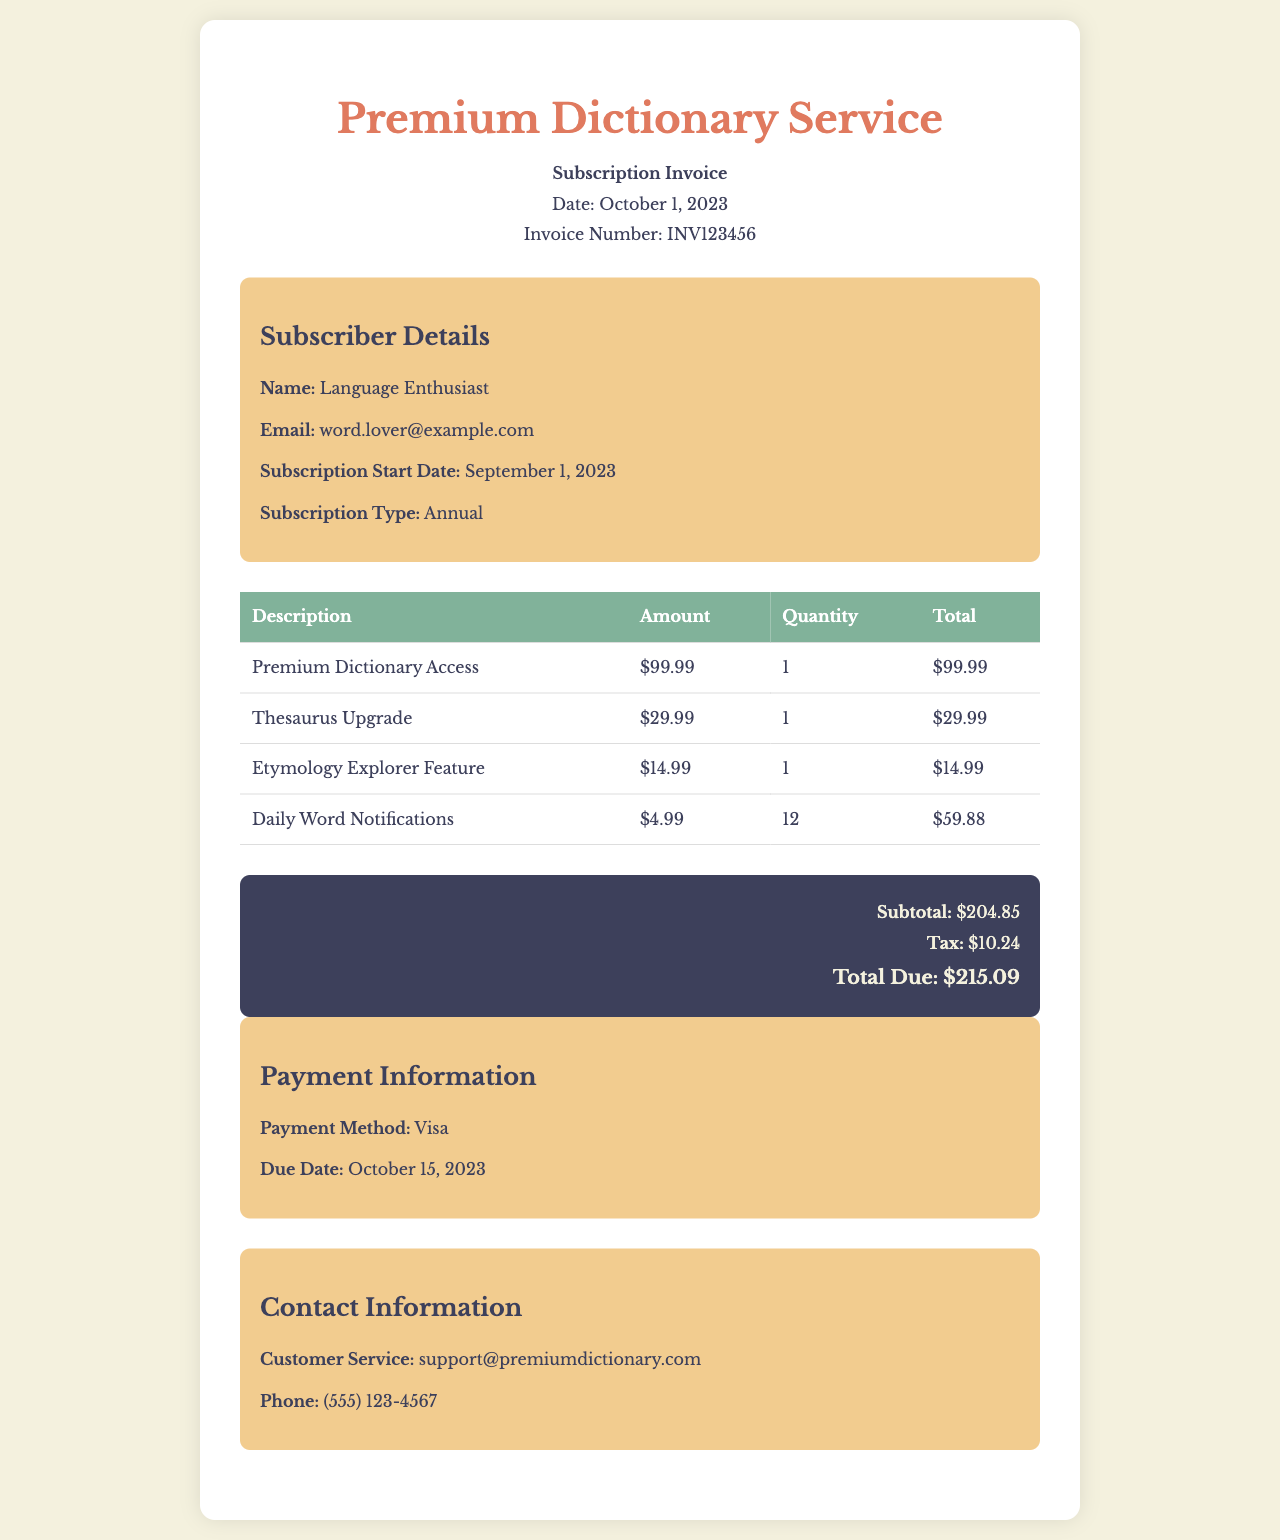What is the subscription type? The subscription type is mentioned in the document and refers to the customer's plan.
Answer: Annual What is the invoice number? The invoice number is a unique identifier provided in the document for reference.
Answer: INV123456 What is the total due amount? The total due amount is the final charge listed at the bottom of the document.
Answer: $215.09 How many Daily Word Notifications are included? The quantity of Daily Word Notifications can be found in the table detailing additional features.
Answer: 12 What is the tax amount? The tax amount is specified in the summary section of the invoice.
Answer: $10.24 What is the due date for payment? The due date for payment is outlined in the payment information section.
Answer: October 15, 2023 What feature costs $14.99? The feature priced at $14.99 is stated in the invoice detailing additional resources.
Answer: Etymology Explorer Feature Who should be contacted for customer service? The contact information for customer support is provided in the document.
Answer: support@premiumdictionary.com What payment method is used? The document specifies the method of payment utilized for this invoice.
Answer: Visa 